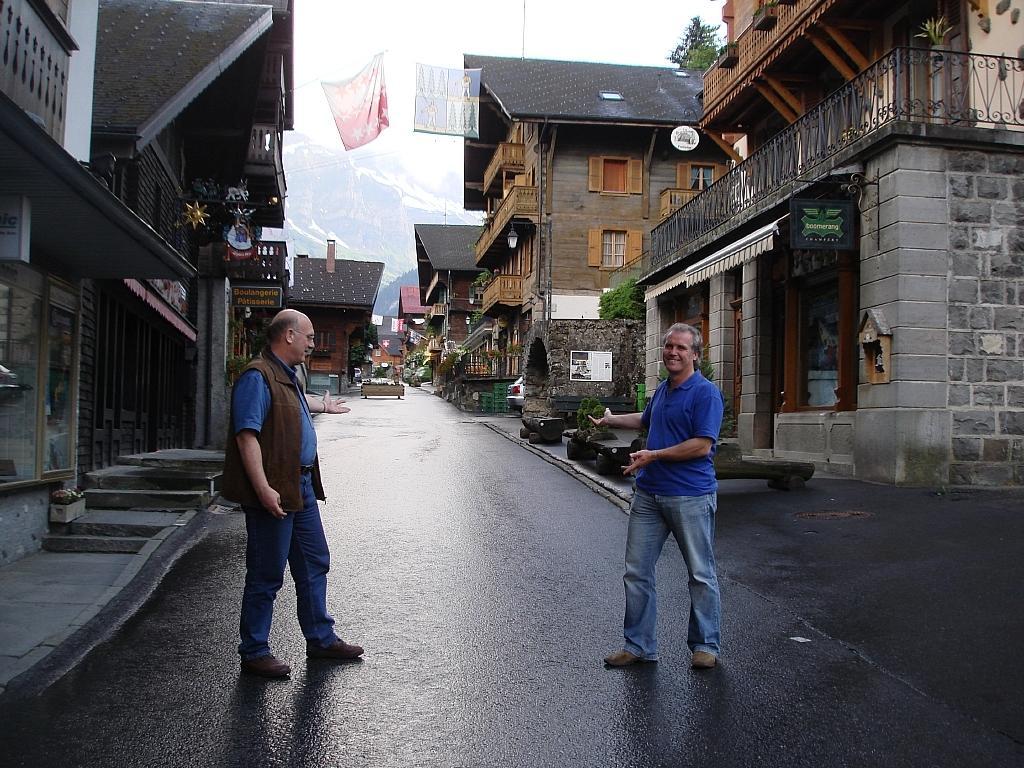Please provide a concise description of this image. In this image there are two people on the road, there are buildings, plants, a tree, few objects near the road and a mountain covered with snow. 